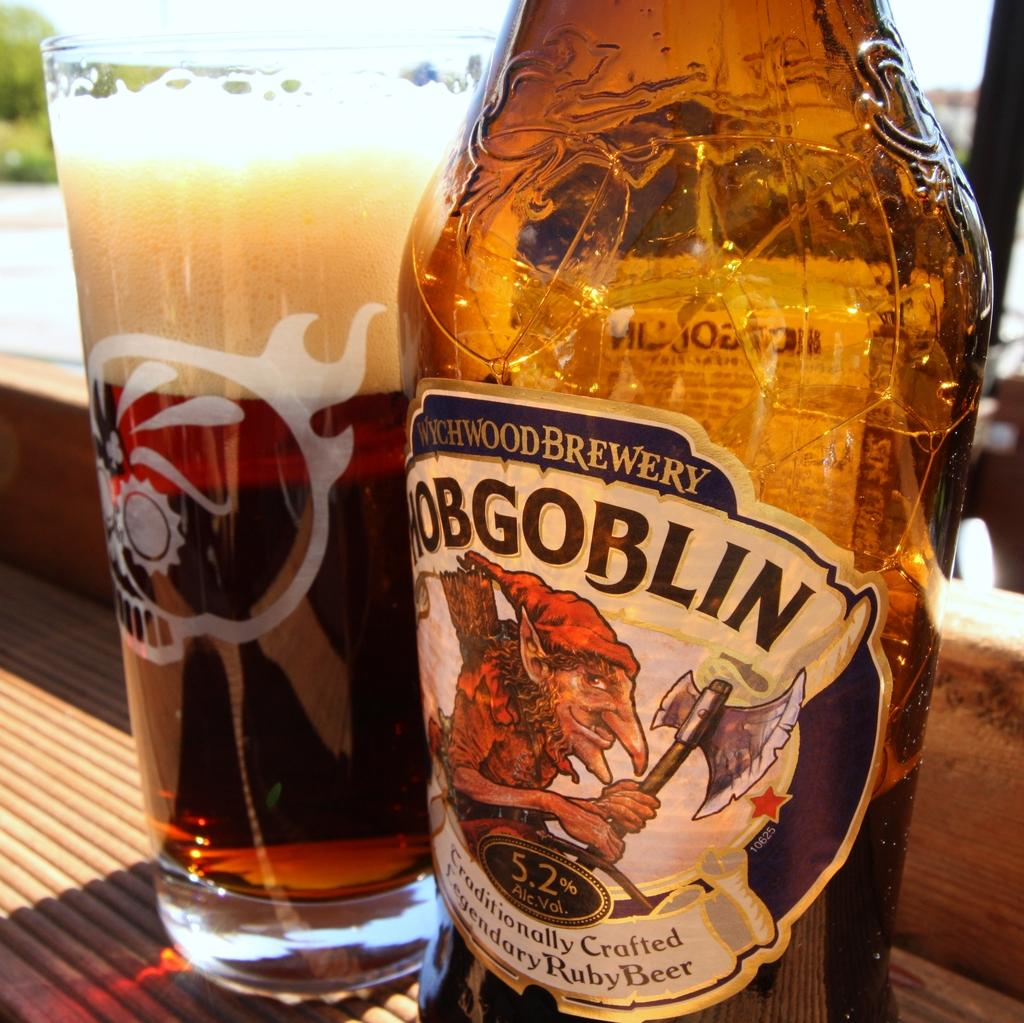What type of container is visible in the image? There is a glass in the image. What other container can be seen in the image? There is a bottle in the image. What type of hammer is being used by the crowd in the image? There is no hammer or crowd present in the image; it only features a glass and a bottle. 